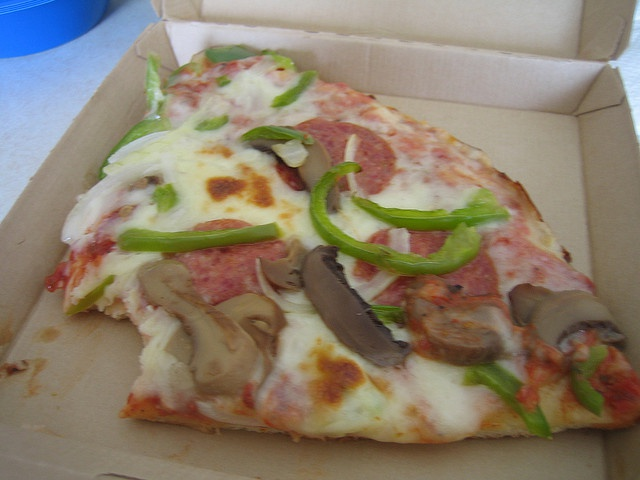Describe the objects in this image and their specific colors. I can see a pizza in blue, olive, darkgray, gray, and tan tones in this image. 